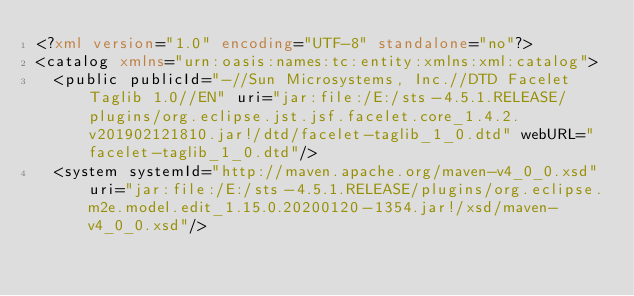<code> <loc_0><loc_0><loc_500><loc_500><_XML_><?xml version="1.0" encoding="UTF-8" standalone="no"?>
<catalog xmlns="urn:oasis:names:tc:entity:xmlns:xml:catalog">
  <public publicId="-//Sun Microsystems, Inc.//DTD Facelet Taglib 1.0//EN" uri="jar:file:/E:/sts-4.5.1.RELEASE/plugins/org.eclipse.jst.jsf.facelet.core_1.4.2.v201902121810.jar!/dtd/facelet-taglib_1_0.dtd" webURL="facelet-taglib_1_0.dtd"/>
  <system systemId="http://maven.apache.org/maven-v4_0_0.xsd" uri="jar:file:/E:/sts-4.5.1.RELEASE/plugins/org.eclipse.m2e.model.edit_1.15.0.20200120-1354.jar!/xsd/maven-v4_0_0.xsd"/></code> 